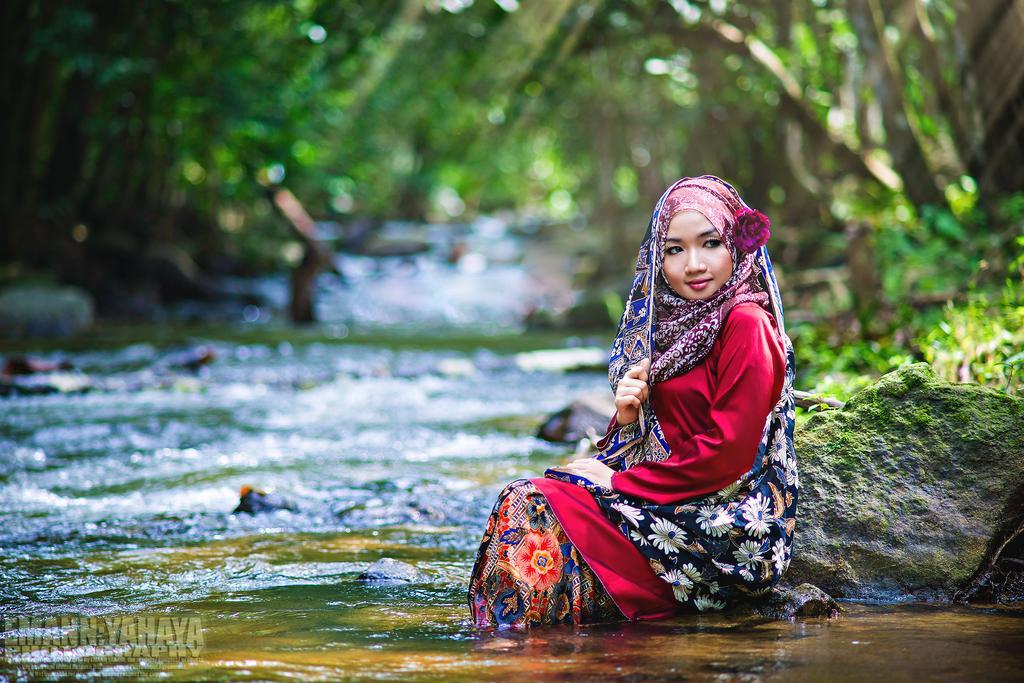In one or two sentences, can you explain what this image depicts? In this image there is a girl sitting on the rocks with feet in the water, behind the girl there is a lake and trees, at the bottom of the image there is some text. 